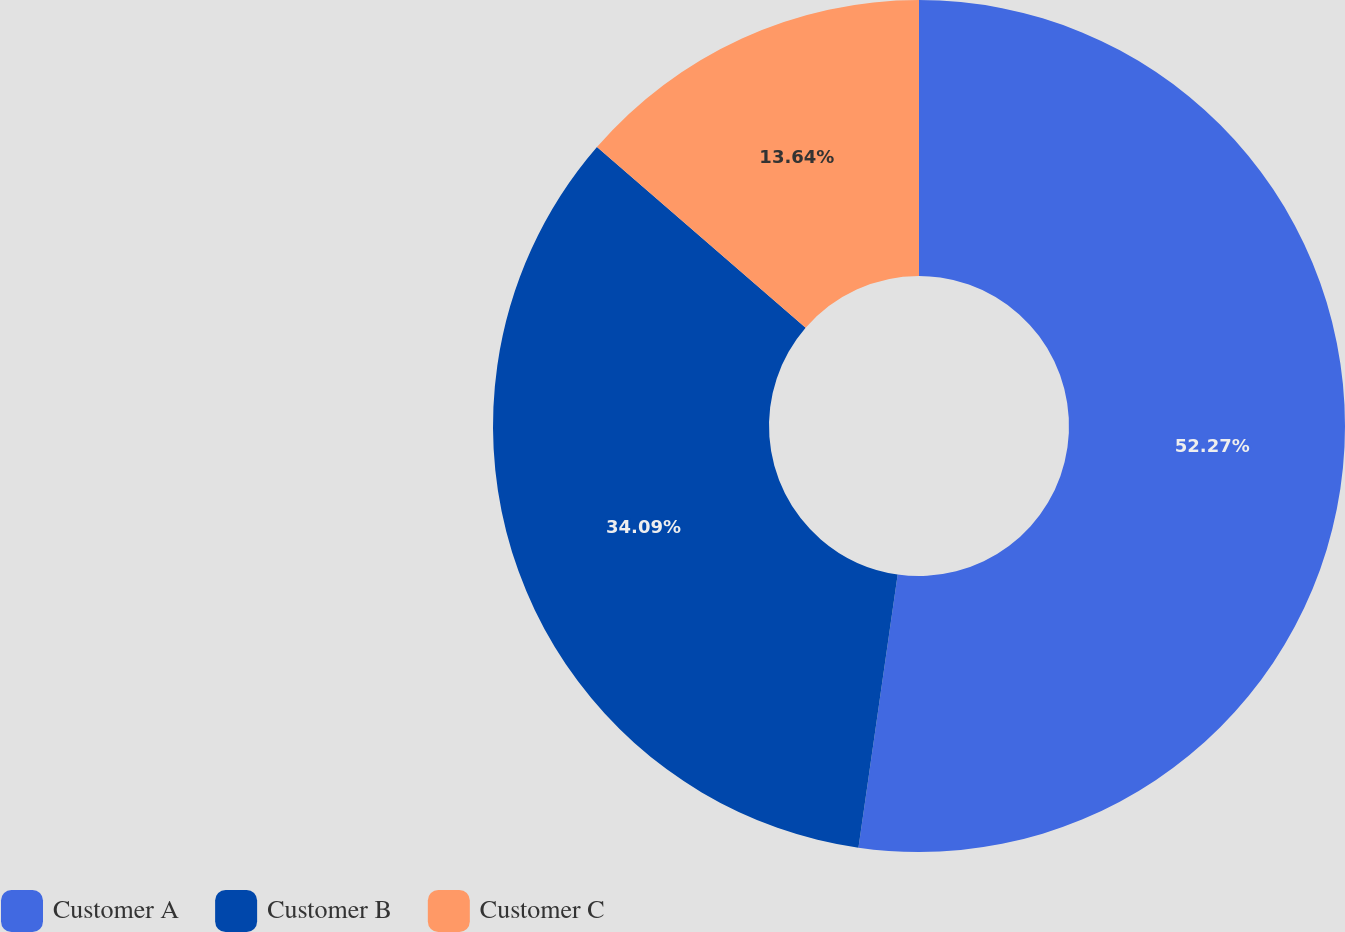Convert chart to OTSL. <chart><loc_0><loc_0><loc_500><loc_500><pie_chart><fcel>Customer A<fcel>Customer B<fcel>Customer C<nl><fcel>52.27%<fcel>34.09%<fcel>13.64%<nl></chart> 